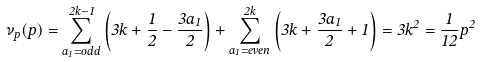<formula> <loc_0><loc_0><loc_500><loc_500>\nu _ { p } ( p ) = \sum _ { a _ { 1 } = o d d } ^ { 2 k - 1 } \left ( 3 k + \frac { 1 } { 2 } - \frac { 3 a _ { 1 } } { 2 } \right ) + \sum _ { a _ { 1 } = e v e n } ^ { 2 k } \left ( 3 k + \frac { 3 a _ { 1 } } { 2 } + 1 \right ) = 3 k ^ { 2 } = \frac { 1 } { 1 2 } p ^ { 2 }</formula> 